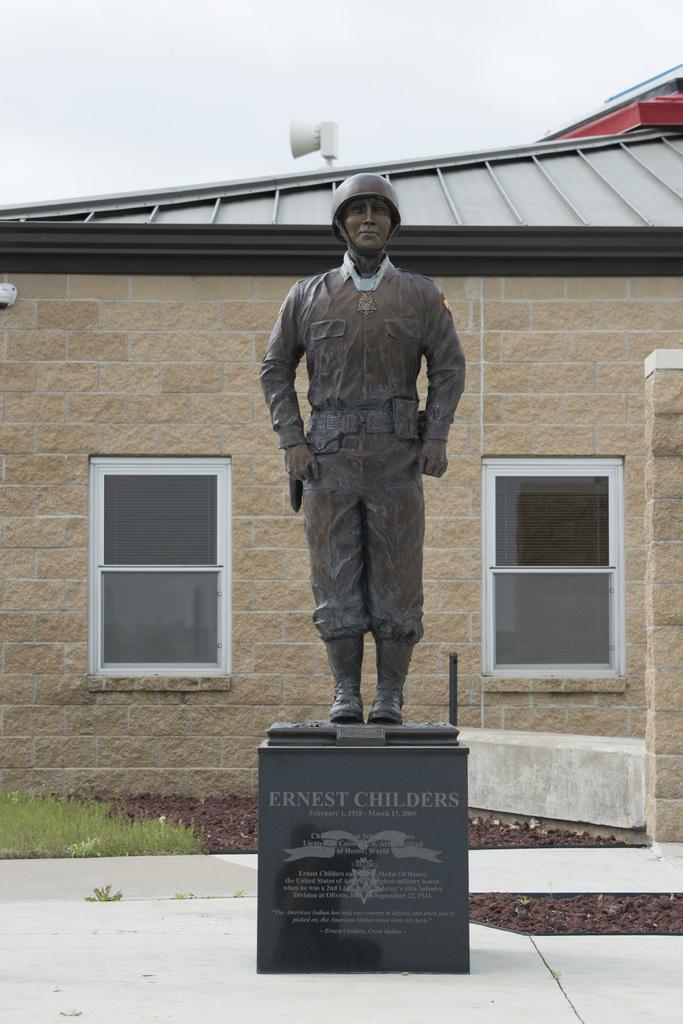Please provide a concise description of this image. Here we can see a statue of a man standing on a platform and on the platform there are texts written on it. In the background we can see a house,windows,roof,grass on the ground,an object on the roof and the sky. 